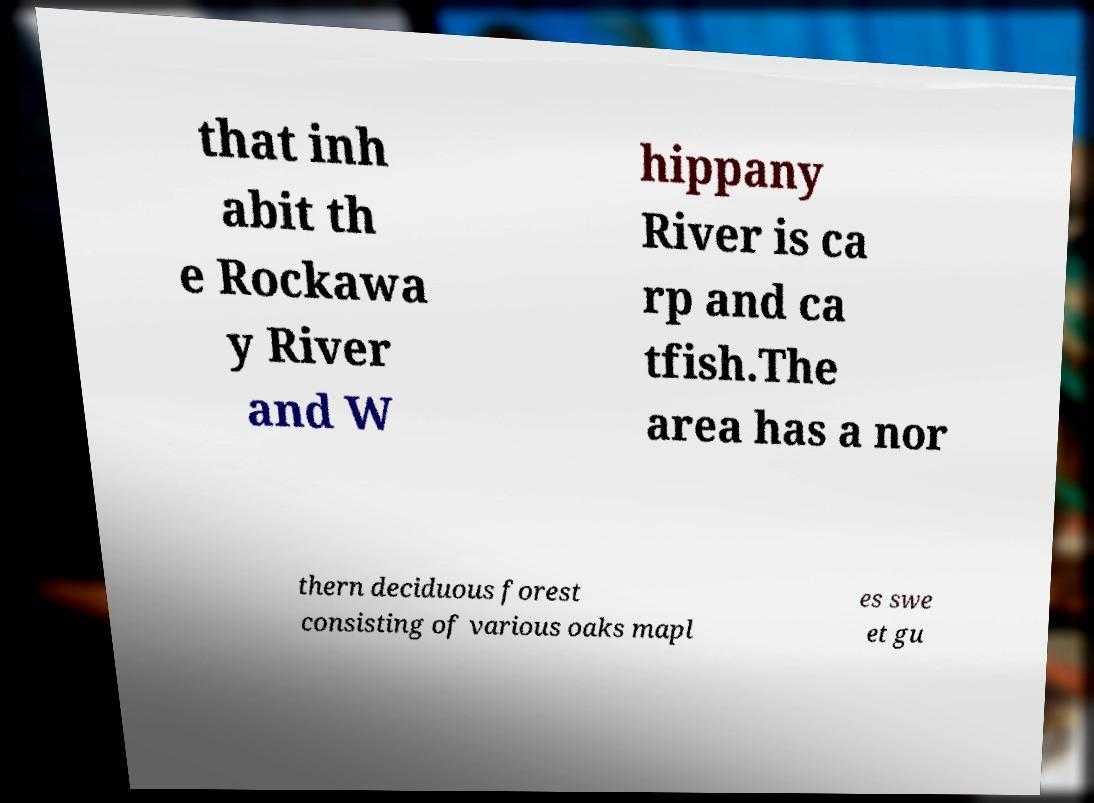For documentation purposes, I need the text within this image transcribed. Could you provide that? that inh abit th e Rockawa y River and W hippany River is ca rp and ca tfish.The area has a nor thern deciduous forest consisting of various oaks mapl es swe et gu 